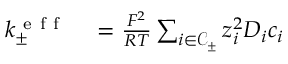Convert formula to latex. <formula><loc_0><loc_0><loc_500><loc_500>\begin{array} { r l } { k _ { \pm } ^ { e f f } } & = \frac { F ^ { 2 } } { R T } \sum _ { i \in \mathcal { C } _ { \pm } } { z _ { i } ^ { 2 } D _ { i } c _ { i } } } \end{array}</formula> 